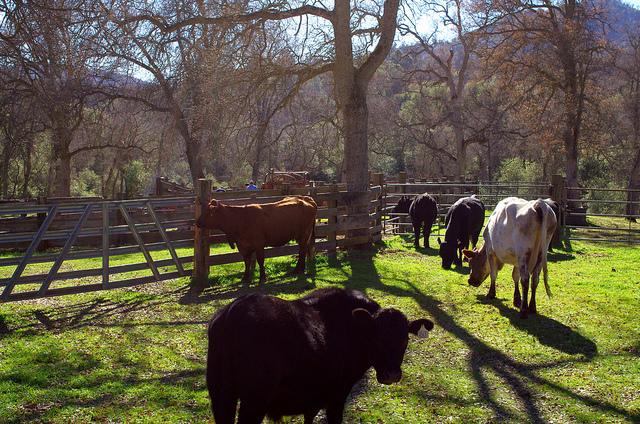Which ear is the cow tagged on?
Write a very short answer. Left. Is there a gate?
Write a very short answer. Yes. What are the posts made of?
Short answer required. Wood. 